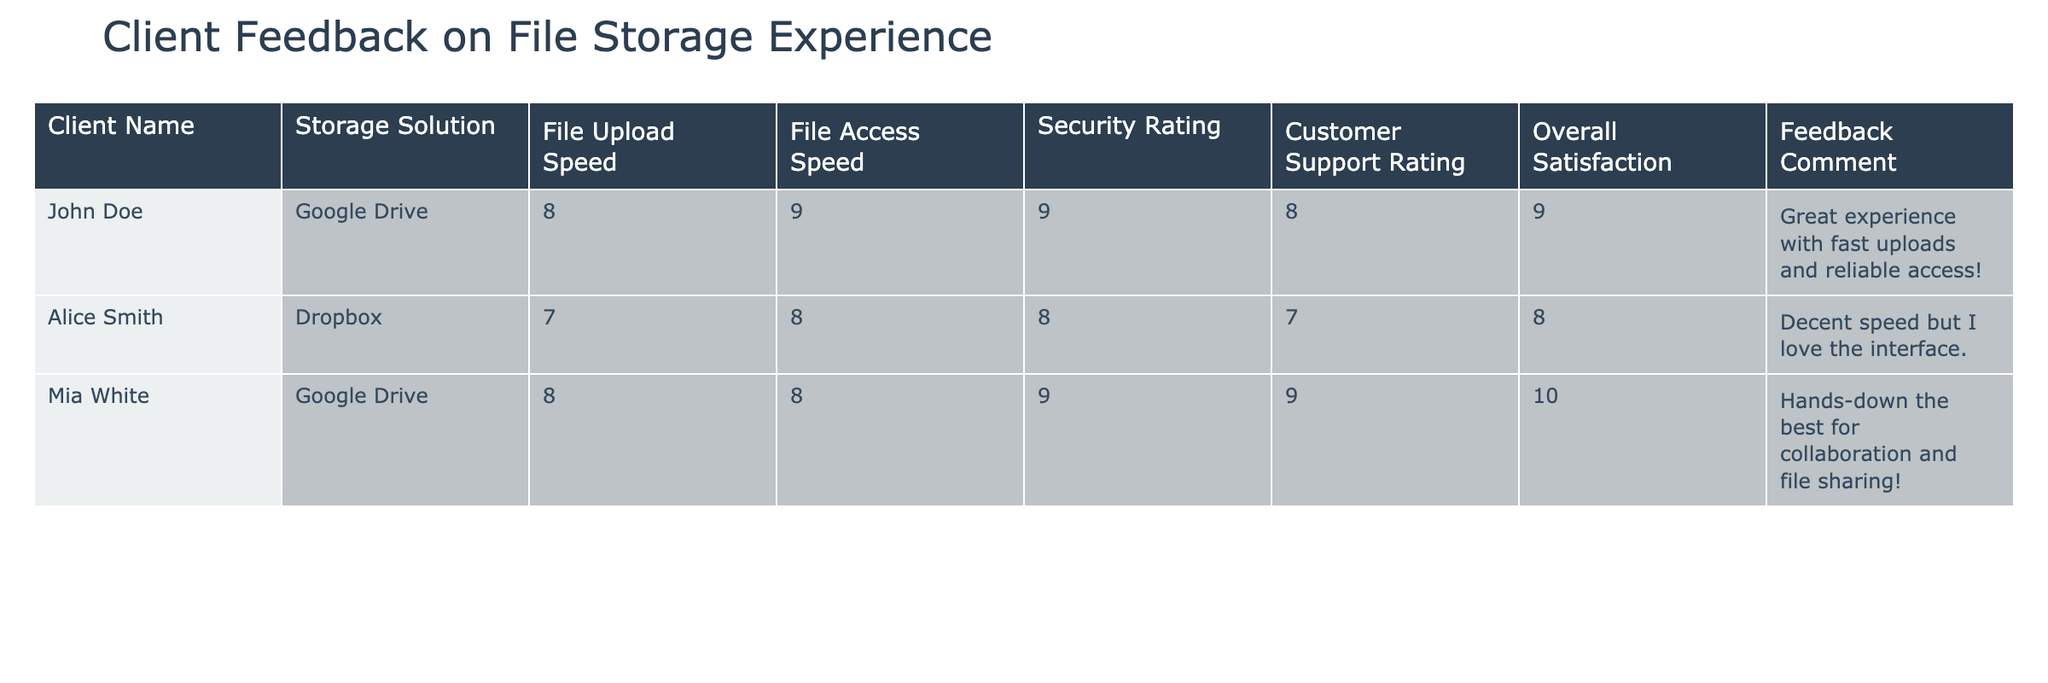What is the Security Rating for Alice Smith's storage solution? The Security Rating for Alice Smith's storage solution, which is Dropbox, can be found in the table under the corresponding column. For Dropbox, the Security Rating is 8.
Answer: 8 What was John Doe's Overall Satisfaction rating? In the table, under the Overall Satisfaction column for John Doe, the rating is listed as 9.
Answer: 9 Which storage solution has the highest File Access Speed? By reviewing the File Access Speed column in the table, Google Drive has a rating of 9, while Dropbox has a rating of 8. Therefore, Google Drive has the highest File Access Speed.
Answer: Google Drive What is the average Overall Satisfaction rating from the provided feedback? To find the average, we will sum the Overall Satisfaction ratings: (9 + 8 + 10) = 27. Then, we divide this sum by the number of clients, which is 3. Hence, the average Overall Satisfaction is 27/3 = 9.
Answer: 9 Did Mia White provide a comment about her experience? By checking the Feedback Comment column for Mia White, we see that she did provide a comment: "Hands-down the best for collaboration and file sharing!" Therefore, the answer is yes.
Answer: Yes Is there a client whose File Upload Speed is below 8? Reviewing the File Upload Speed column, John Doe and Mia White both have a speed of 8, while Alice Smith has a speed of 7. Therefore, there is a client whose File Upload Speed is below 8, which is Alice Smith.
Answer: Yes Which client rated Security the highest and what was their rating? Looking at the Security Rating column, Mia White rated Security at 9, which is the highest among the clients listed. Therefore, Mia White rated Security the highest.
Answer: Mia White, 9 How does John Doe's File Upload Speed compare with Mia White's? John Doe's File Upload Speed is 8, while Mia White's File Upload Speed is also 8. Therefore, they are the same, which can be stated as having no difference.
Answer: They are the same What client was most satisfied with their file storage overall? To determine overall satisfaction, we review the Overall Satisfaction column and see that Mia White rated it 10, which is the highest rating provided. Thus, Mia White is the most satisfied.
Answer: Mia White 